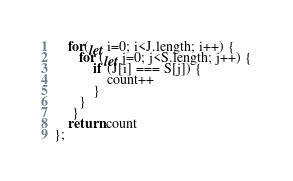Convert code to text. <code><loc_0><loc_0><loc_500><loc_500><_JavaScript_>    for(let i=0; i<J.length; i++) {
       for (let j=0; j<S.length; j++) {
           if (J[i] === S[j]) {
               count++
           }
       }
     }
    return count
};
</code> 